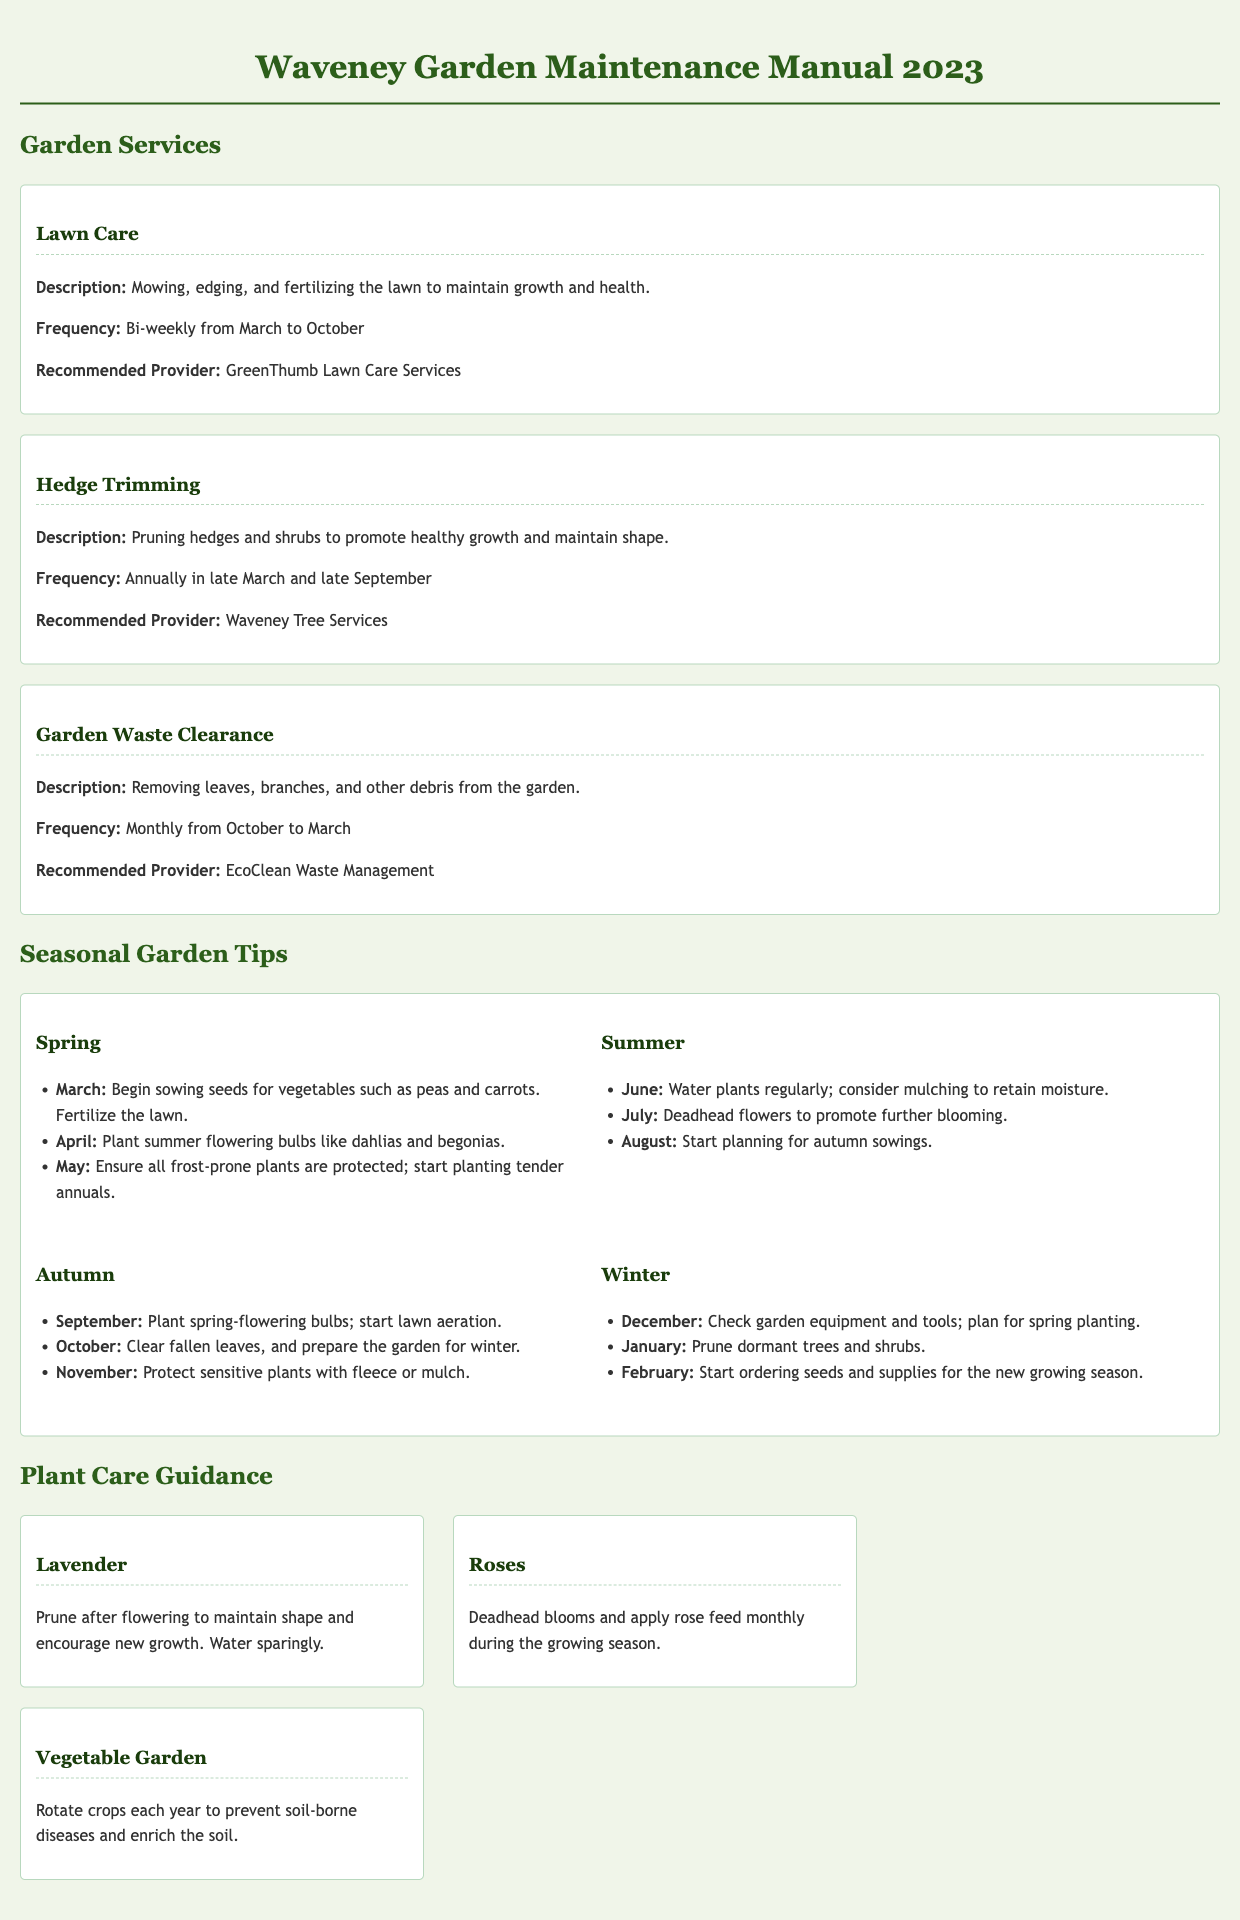what is the frequency of lawn care services? The document states that lawn care services are provided bi-weekly from March to October.
Answer: Bi-weekly from March to October who is the recommended provider for hedge trimming? The document specifies Waveney Tree Services as the recommended provider for hedge trimming.
Answer: Waveney Tree Services when should you start planting tender annuals? According to the seasonal tips, tender annuals should be planted in May.
Answer: May what action is recommended for roses during the growing season? The document advises deadheading blooms and applying rose feed monthly during the growing season.
Answer: Deadhead blooms and apply rose feed monthly how often should garden waste clearance be performed? The document indicates that garden waste clearance should occur monthly from October to March.
Answer: Monthly from October to March what is a seasonal task to be done in October? The document suggests clearing fallen leaves and preparing the garden for winter as a task for October.
Answer: Clear fallen leaves, and prepare the garden for winter which month should you start ordering seeds for the new growing season? According to the winter tips, seeds and supplies should be ordered in February.
Answer: February how should lavender be cared for? The document states that lavender should be pruned after flowering to maintain shape and encourage new growth.
Answer: Prune after flowering what seasonal task is suggested for September? The document suggests planting spring-flowering bulbs in September.
Answer: Plant spring-flowering bulbs 